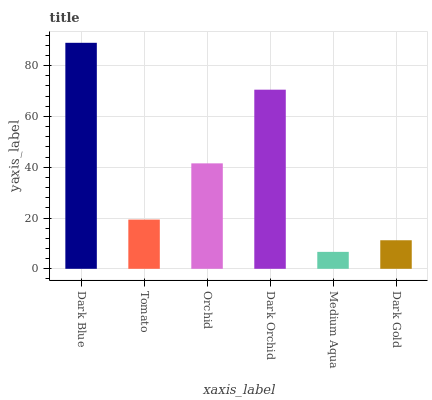Is Medium Aqua the minimum?
Answer yes or no. Yes. Is Dark Blue the maximum?
Answer yes or no. Yes. Is Tomato the minimum?
Answer yes or no. No. Is Tomato the maximum?
Answer yes or no. No. Is Dark Blue greater than Tomato?
Answer yes or no. Yes. Is Tomato less than Dark Blue?
Answer yes or no. Yes. Is Tomato greater than Dark Blue?
Answer yes or no. No. Is Dark Blue less than Tomato?
Answer yes or no. No. Is Orchid the high median?
Answer yes or no. Yes. Is Tomato the low median?
Answer yes or no. Yes. Is Dark Orchid the high median?
Answer yes or no. No. Is Orchid the low median?
Answer yes or no. No. 